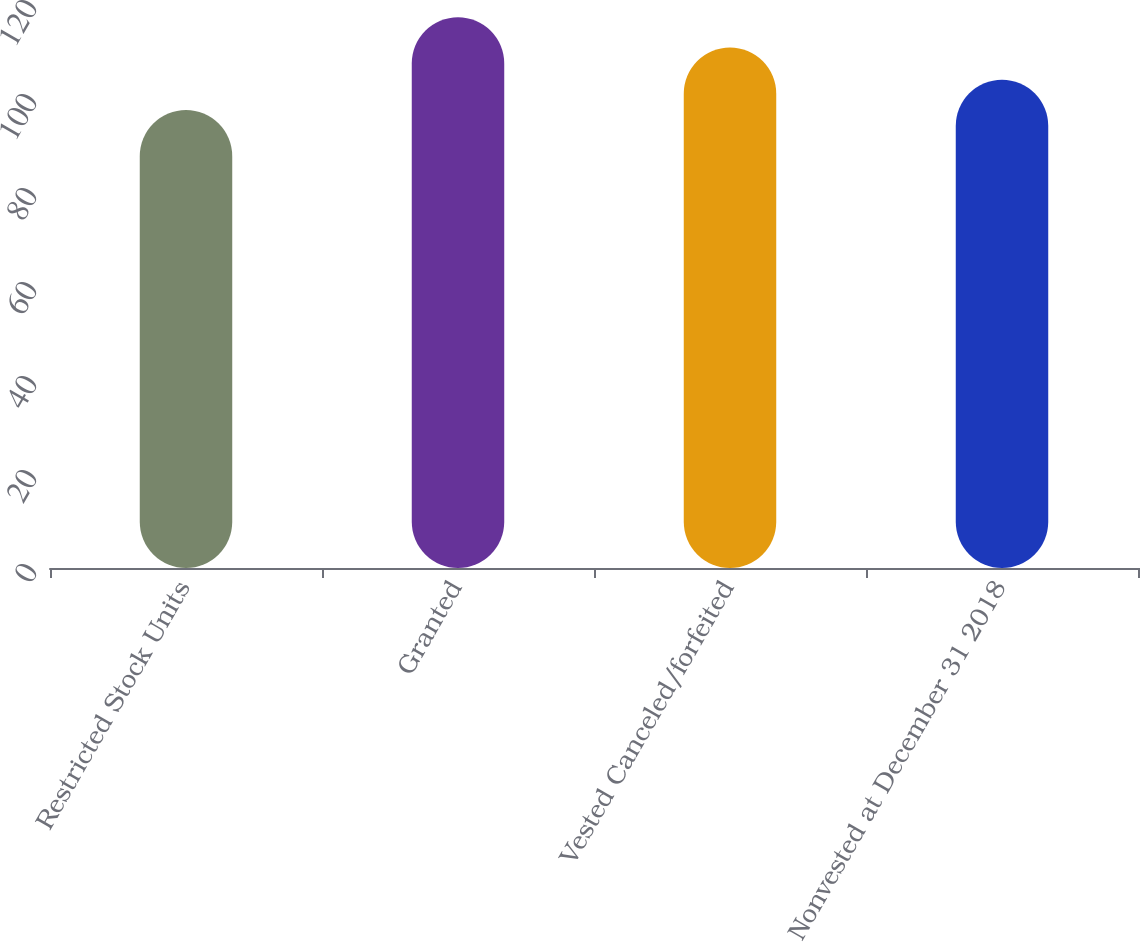Convert chart to OTSL. <chart><loc_0><loc_0><loc_500><loc_500><bar_chart><fcel>Restricted Stock Units<fcel>Granted<fcel>Vested Canceled/forfeited<fcel>Nonvested at December 31 2018<nl><fcel>97.43<fcel>117.2<fcel>110.73<fcel>103.88<nl></chart> 